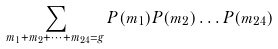Convert formula to latex. <formula><loc_0><loc_0><loc_500><loc_500>\sum _ { m _ { 1 } + m _ { 2 } + \dots + m _ { 2 4 } = g } P ( m _ { 1 } ) P ( m _ { 2 } ) \dots P ( m _ { 2 4 } )</formula> 